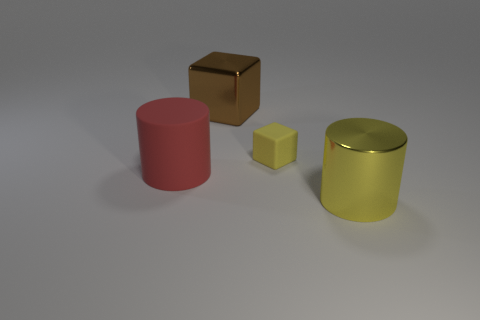There is a cylinder that is to the left of the brown metal cube; does it have the same size as the metal block? The red cylinder on the left appears to be of a different size when compared to the brown metal cube. Without specific measurements, it's challenging to determine if they have the exact same size. However, visually, the cylinder seems to have a larger diameter but might be shorter in height than the cube, which suggests their volumes could be different. 